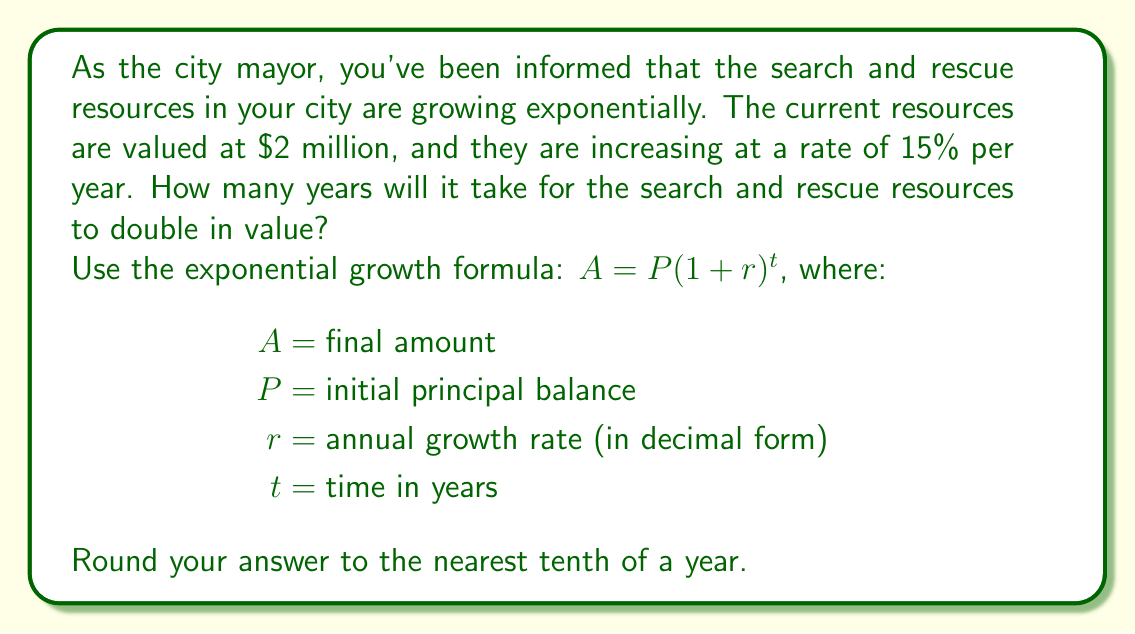Could you help me with this problem? To solve this problem, we'll use the exponential growth formula and the concept of doubling time:

1) We know that:
   $P = $2 million (initial value)
   $r = 15\% = 0.15$ (growth rate in decimal form)
   $A = $4 million (double the initial value)

2) We need to find $t$ (time in years). Let's set up the equation:

   $A = P(1 + r)^t$
   $4 = 2(1 + 0.15)^t$

3) Divide both sides by 2:
   $2 = (1.15)^t$

4) Take the natural logarithm of both sides:
   $\ln(2) = t \cdot \ln(1.15)$

5) Solve for $t$:
   $t = \frac{\ln(2)}{\ln(1.15)}$

6) Use a calculator to compute:
   $t = \frac{0.693147181}{0.139762228} \approx 4.959$ years

7) Rounding to the nearest tenth:
   $t \approx 5.0$ years

This result aligns with the "Rule of 72," which is a quick estimation method for doubling time: $72 \div \text{growth rate percentage} \approx \text{years to double}$. In this case, $72 \div 15 = 4.8$ years, which is close to our calculated result.
Answer: It will take approximately 5.0 years for the search and rescue resources to double in value. 